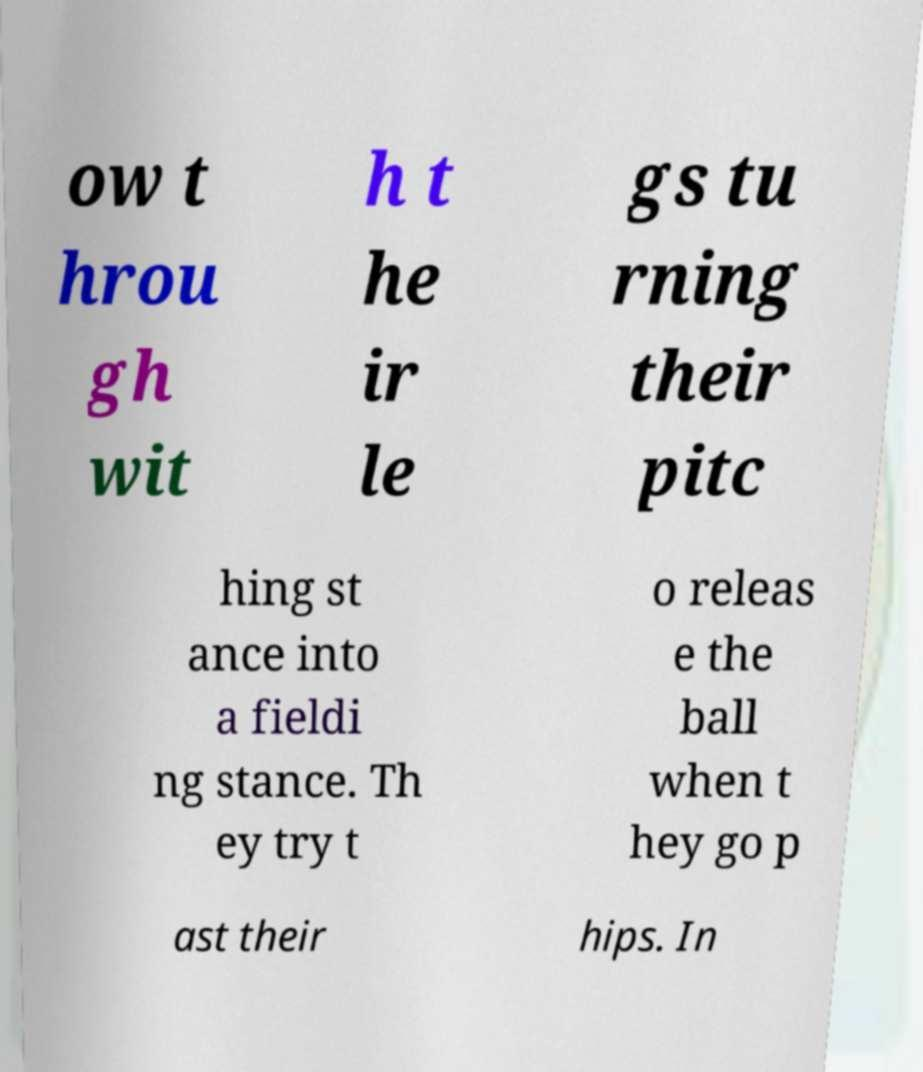I need the written content from this picture converted into text. Can you do that? ow t hrou gh wit h t he ir le gs tu rning their pitc hing st ance into a fieldi ng stance. Th ey try t o releas e the ball when t hey go p ast their hips. In 